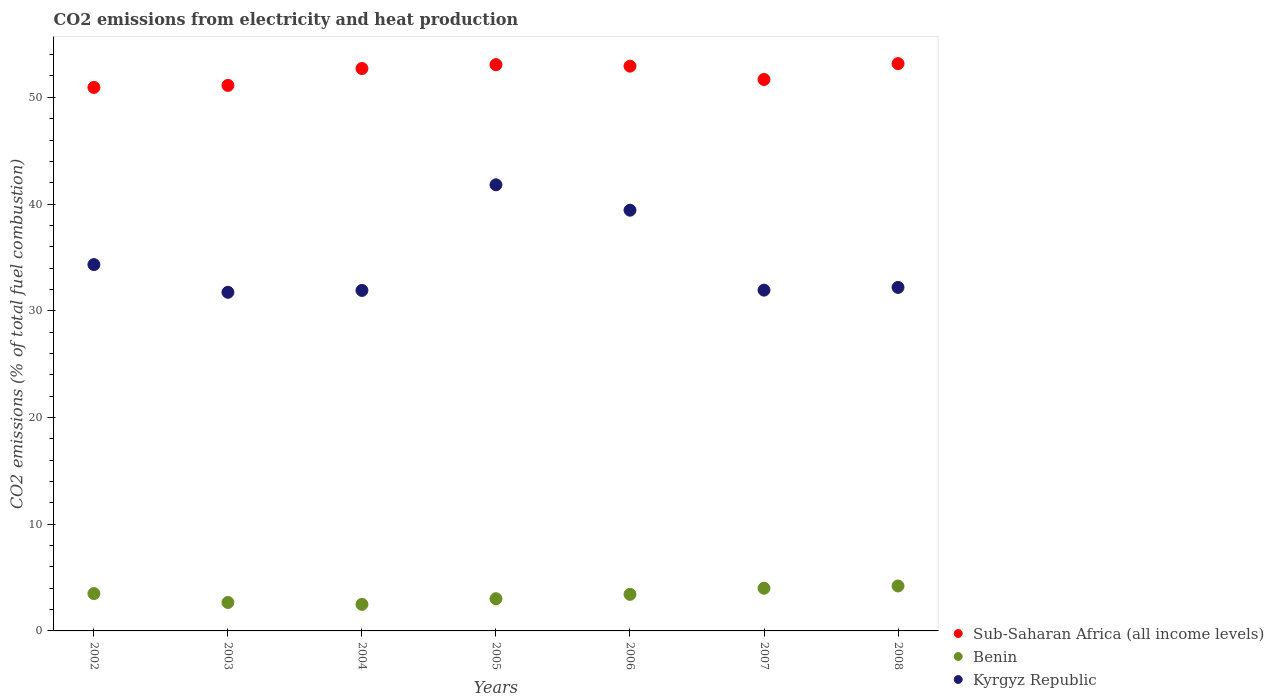How many different coloured dotlines are there?
Your answer should be compact. 3. What is the amount of CO2 emitted in Kyrgyz Republic in 2004?
Your answer should be very brief. 31.91. Across all years, what is the maximum amount of CO2 emitted in Benin?
Offer a terse response. 4.21. Across all years, what is the minimum amount of CO2 emitted in Benin?
Your answer should be very brief. 2.49. In which year was the amount of CO2 emitted in Sub-Saharan Africa (all income levels) minimum?
Provide a short and direct response. 2002. What is the total amount of CO2 emitted in Sub-Saharan Africa (all income levels) in the graph?
Provide a succinct answer. 365.57. What is the difference between the amount of CO2 emitted in Benin in 2005 and that in 2006?
Make the answer very short. -0.41. What is the difference between the amount of CO2 emitted in Benin in 2003 and the amount of CO2 emitted in Kyrgyz Republic in 2007?
Ensure brevity in your answer.  -29.27. What is the average amount of CO2 emitted in Sub-Saharan Africa (all income levels) per year?
Provide a short and direct response. 52.22. In the year 2006, what is the difference between the amount of CO2 emitted in Sub-Saharan Africa (all income levels) and amount of CO2 emitted in Benin?
Keep it short and to the point. 49.5. What is the ratio of the amount of CO2 emitted in Kyrgyz Republic in 2003 to that in 2007?
Offer a very short reply. 0.99. Is the difference between the amount of CO2 emitted in Sub-Saharan Africa (all income levels) in 2003 and 2007 greater than the difference between the amount of CO2 emitted in Benin in 2003 and 2007?
Provide a succinct answer. Yes. What is the difference between the highest and the second highest amount of CO2 emitted in Benin?
Provide a succinct answer. 0.21. What is the difference between the highest and the lowest amount of CO2 emitted in Kyrgyz Republic?
Provide a short and direct response. 10.07. In how many years, is the amount of CO2 emitted in Sub-Saharan Africa (all income levels) greater than the average amount of CO2 emitted in Sub-Saharan Africa (all income levels) taken over all years?
Offer a very short reply. 4. Is the sum of the amount of CO2 emitted in Benin in 2003 and 2005 greater than the maximum amount of CO2 emitted in Sub-Saharan Africa (all income levels) across all years?
Keep it short and to the point. No. Is it the case that in every year, the sum of the amount of CO2 emitted in Benin and amount of CO2 emitted in Kyrgyz Republic  is greater than the amount of CO2 emitted in Sub-Saharan Africa (all income levels)?
Give a very brief answer. No. How many years are there in the graph?
Provide a succinct answer. 7. What is the difference between two consecutive major ticks on the Y-axis?
Ensure brevity in your answer.  10. Are the values on the major ticks of Y-axis written in scientific E-notation?
Provide a succinct answer. No. Does the graph contain grids?
Provide a succinct answer. No. Where does the legend appear in the graph?
Provide a short and direct response. Bottom right. What is the title of the graph?
Keep it short and to the point. CO2 emissions from electricity and heat production. What is the label or title of the Y-axis?
Your answer should be compact. CO2 emissions (% of total fuel combustion). What is the CO2 emissions (% of total fuel combustion) in Sub-Saharan Africa (all income levels) in 2002?
Provide a short and direct response. 50.93. What is the CO2 emissions (% of total fuel combustion) in Benin in 2002?
Keep it short and to the point. 3.5. What is the CO2 emissions (% of total fuel combustion) of Kyrgyz Republic in 2002?
Provide a short and direct response. 34.33. What is the CO2 emissions (% of total fuel combustion) in Sub-Saharan Africa (all income levels) in 2003?
Give a very brief answer. 51.12. What is the CO2 emissions (% of total fuel combustion) of Benin in 2003?
Provide a short and direct response. 2.67. What is the CO2 emissions (% of total fuel combustion) of Kyrgyz Republic in 2003?
Keep it short and to the point. 31.73. What is the CO2 emissions (% of total fuel combustion) in Sub-Saharan Africa (all income levels) in 2004?
Your answer should be compact. 52.7. What is the CO2 emissions (% of total fuel combustion) in Benin in 2004?
Ensure brevity in your answer.  2.49. What is the CO2 emissions (% of total fuel combustion) of Kyrgyz Republic in 2004?
Offer a very short reply. 31.91. What is the CO2 emissions (% of total fuel combustion) of Sub-Saharan Africa (all income levels) in 2005?
Your response must be concise. 53.06. What is the CO2 emissions (% of total fuel combustion) of Benin in 2005?
Your answer should be compact. 3.02. What is the CO2 emissions (% of total fuel combustion) in Kyrgyz Republic in 2005?
Your answer should be compact. 41.8. What is the CO2 emissions (% of total fuel combustion) of Sub-Saharan Africa (all income levels) in 2006?
Offer a very short reply. 52.92. What is the CO2 emissions (% of total fuel combustion) in Benin in 2006?
Provide a short and direct response. 3.43. What is the CO2 emissions (% of total fuel combustion) in Kyrgyz Republic in 2006?
Offer a terse response. 39.43. What is the CO2 emissions (% of total fuel combustion) of Sub-Saharan Africa (all income levels) in 2007?
Make the answer very short. 51.67. What is the CO2 emissions (% of total fuel combustion) of Benin in 2007?
Offer a very short reply. 4. What is the CO2 emissions (% of total fuel combustion) of Kyrgyz Republic in 2007?
Give a very brief answer. 31.93. What is the CO2 emissions (% of total fuel combustion) of Sub-Saharan Africa (all income levels) in 2008?
Offer a very short reply. 53.16. What is the CO2 emissions (% of total fuel combustion) in Benin in 2008?
Provide a succinct answer. 4.21. What is the CO2 emissions (% of total fuel combustion) of Kyrgyz Republic in 2008?
Your response must be concise. 32.19. Across all years, what is the maximum CO2 emissions (% of total fuel combustion) in Sub-Saharan Africa (all income levels)?
Provide a short and direct response. 53.16. Across all years, what is the maximum CO2 emissions (% of total fuel combustion) in Benin?
Offer a terse response. 4.21. Across all years, what is the maximum CO2 emissions (% of total fuel combustion) in Kyrgyz Republic?
Your answer should be compact. 41.8. Across all years, what is the minimum CO2 emissions (% of total fuel combustion) of Sub-Saharan Africa (all income levels)?
Your response must be concise. 50.93. Across all years, what is the minimum CO2 emissions (% of total fuel combustion) in Benin?
Your response must be concise. 2.49. Across all years, what is the minimum CO2 emissions (% of total fuel combustion) of Kyrgyz Republic?
Provide a succinct answer. 31.73. What is the total CO2 emissions (% of total fuel combustion) in Sub-Saharan Africa (all income levels) in the graph?
Provide a succinct answer. 365.57. What is the total CO2 emissions (% of total fuel combustion) of Benin in the graph?
Provide a short and direct response. 23.31. What is the total CO2 emissions (% of total fuel combustion) of Kyrgyz Republic in the graph?
Your answer should be very brief. 243.32. What is the difference between the CO2 emissions (% of total fuel combustion) in Sub-Saharan Africa (all income levels) in 2002 and that in 2003?
Your response must be concise. -0.19. What is the difference between the CO2 emissions (% of total fuel combustion) in Benin in 2002 and that in 2003?
Make the answer very short. 0.83. What is the difference between the CO2 emissions (% of total fuel combustion) in Kyrgyz Republic in 2002 and that in 2003?
Your answer should be compact. 2.6. What is the difference between the CO2 emissions (% of total fuel combustion) of Sub-Saharan Africa (all income levels) in 2002 and that in 2004?
Ensure brevity in your answer.  -1.77. What is the difference between the CO2 emissions (% of total fuel combustion) in Benin in 2002 and that in 2004?
Offer a terse response. 1.01. What is the difference between the CO2 emissions (% of total fuel combustion) in Kyrgyz Republic in 2002 and that in 2004?
Make the answer very short. 2.42. What is the difference between the CO2 emissions (% of total fuel combustion) of Sub-Saharan Africa (all income levels) in 2002 and that in 2005?
Your answer should be compact. -2.13. What is the difference between the CO2 emissions (% of total fuel combustion) in Benin in 2002 and that in 2005?
Provide a short and direct response. 0.48. What is the difference between the CO2 emissions (% of total fuel combustion) of Kyrgyz Republic in 2002 and that in 2005?
Keep it short and to the point. -7.47. What is the difference between the CO2 emissions (% of total fuel combustion) of Sub-Saharan Africa (all income levels) in 2002 and that in 2006?
Offer a terse response. -1.99. What is the difference between the CO2 emissions (% of total fuel combustion) of Benin in 2002 and that in 2006?
Provide a succinct answer. 0.07. What is the difference between the CO2 emissions (% of total fuel combustion) of Kyrgyz Republic in 2002 and that in 2006?
Give a very brief answer. -5.1. What is the difference between the CO2 emissions (% of total fuel combustion) of Sub-Saharan Africa (all income levels) in 2002 and that in 2007?
Your answer should be very brief. -0.74. What is the difference between the CO2 emissions (% of total fuel combustion) of Kyrgyz Republic in 2002 and that in 2007?
Give a very brief answer. 2.4. What is the difference between the CO2 emissions (% of total fuel combustion) in Sub-Saharan Africa (all income levels) in 2002 and that in 2008?
Keep it short and to the point. -2.23. What is the difference between the CO2 emissions (% of total fuel combustion) in Benin in 2002 and that in 2008?
Your answer should be very brief. -0.71. What is the difference between the CO2 emissions (% of total fuel combustion) in Kyrgyz Republic in 2002 and that in 2008?
Your answer should be compact. 2.14. What is the difference between the CO2 emissions (% of total fuel combustion) of Sub-Saharan Africa (all income levels) in 2003 and that in 2004?
Give a very brief answer. -1.58. What is the difference between the CO2 emissions (% of total fuel combustion) in Benin in 2003 and that in 2004?
Make the answer very short. 0.18. What is the difference between the CO2 emissions (% of total fuel combustion) of Kyrgyz Republic in 2003 and that in 2004?
Keep it short and to the point. -0.18. What is the difference between the CO2 emissions (% of total fuel combustion) in Sub-Saharan Africa (all income levels) in 2003 and that in 2005?
Your answer should be very brief. -1.94. What is the difference between the CO2 emissions (% of total fuel combustion) in Benin in 2003 and that in 2005?
Give a very brief answer. -0.35. What is the difference between the CO2 emissions (% of total fuel combustion) in Kyrgyz Republic in 2003 and that in 2005?
Keep it short and to the point. -10.07. What is the difference between the CO2 emissions (% of total fuel combustion) of Sub-Saharan Africa (all income levels) in 2003 and that in 2006?
Your answer should be compact. -1.8. What is the difference between the CO2 emissions (% of total fuel combustion) in Benin in 2003 and that in 2006?
Make the answer very short. -0.76. What is the difference between the CO2 emissions (% of total fuel combustion) of Kyrgyz Republic in 2003 and that in 2006?
Keep it short and to the point. -7.69. What is the difference between the CO2 emissions (% of total fuel combustion) of Sub-Saharan Africa (all income levels) in 2003 and that in 2007?
Offer a terse response. -0.55. What is the difference between the CO2 emissions (% of total fuel combustion) in Benin in 2003 and that in 2007?
Offer a terse response. -1.33. What is the difference between the CO2 emissions (% of total fuel combustion) of Kyrgyz Republic in 2003 and that in 2007?
Ensure brevity in your answer.  -0.2. What is the difference between the CO2 emissions (% of total fuel combustion) of Sub-Saharan Africa (all income levels) in 2003 and that in 2008?
Ensure brevity in your answer.  -2.04. What is the difference between the CO2 emissions (% of total fuel combustion) of Benin in 2003 and that in 2008?
Keep it short and to the point. -1.54. What is the difference between the CO2 emissions (% of total fuel combustion) in Kyrgyz Republic in 2003 and that in 2008?
Offer a very short reply. -0.46. What is the difference between the CO2 emissions (% of total fuel combustion) in Sub-Saharan Africa (all income levels) in 2004 and that in 2005?
Give a very brief answer. -0.36. What is the difference between the CO2 emissions (% of total fuel combustion) in Benin in 2004 and that in 2005?
Your answer should be compact. -0.53. What is the difference between the CO2 emissions (% of total fuel combustion) in Kyrgyz Republic in 2004 and that in 2005?
Offer a very short reply. -9.9. What is the difference between the CO2 emissions (% of total fuel combustion) of Sub-Saharan Africa (all income levels) in 2004 and that in 2006?
Make the answer very short. -0.22. What is the difference between the CO2 emissions (% of total fuel combustion) in Benin in 2004 and that in 2006?
Your answer should be very brief. -0.94. What is the difference between the CO2 emissions (% of total fuel combustion) of Kyrgyz Republic in 2004 and that in 2006?
Provide a succinct answer. -7.52. What is the difference between the CO2 emissions (% of total fuel combustion) in Sub-Saharan Africa (all income levels) in 2004 and that in 2007?
Your answer should be very brief. 1.03. What is the difference between the CO2 emissions (% of total fuel combustion) of Benin in 2004 and that in 2007?
Ensure brevity in your answer.  -1.51. What is the difference between the CO2 emissions (% of total fuel combustion) in Kyrgyz Republic in 2004 and that in 2007?
Provide a succinct answer. -0.03. What is the difference between the CO2 emissions (% of total fuel combustion) of Sub-Saharan Africa (all income levels) in 2004 and that in 2008?
Your response must be concise. -0.46. What is the difference between the CO2 emissions (% of total fuel combustion) in Benin in 2004 and that in 2008?
Provide a succinct answer. -1.72. What is the difference between the CO2 emissions (% of total fuel combustion) in Kyrgyz Republic in 2004 and that in 2008?
Make the answer very short. -0.28. What is the difference between the CO2 emissions (% of total fuel combustion) in Sub-Saharan Africa (all income levels) in 2005 and that in 2006?
Keep it short and to the point. 0.14. What is the difference between the CO2 emissions (% of total fuel combustion) in Benin in 2005 and that in 2006?
Ensure brevity in your answer.  -0.41. What is the difference between the CO2 emissions (% of total fuel combustion) in Kyrgyz Republic in 2005 and that in 2006?
Your answer should be compact. 2.38. What is the difference between the CO2 emissions (% of total fuel combustion) of Sub-Saharan Africa (all income levels) in 2005 and that in 2007?
Offer a very short reply. 1.39. What is the difference between the CO2 emissions (% of total fuel combustion) in Benin in 2005 and that in 2007?
Offer a very short reply. -0.98. What is the difference between the CO2 emissions (% of total fuel combustion) in Kyrgyz Republic in 2005 and that in 2007?
Your answer should be compact. 9.87. What is the difference between the CO2 emissions (% of total fuel combustion) in Sub-Saharan Africa (all income levels) in 2005 and that in 2008?
Keep it short and to the point. -0.1. What is the difference between the CO2 emissions (% of total fuel combustion) in Benin in 2005 and that in 2008?
Your answer should be very brief. -1.19. What is the difference between the CO2 emissions (% of total fuel combustion) in Kyrgyz Republic in 2005 and that in 2008?
Your answer should be compact. 9.61. What is the difference between the CO2 emissions (% of total fuel combustion) of Sub-Saharan Africa (all income levels) in 2006 and that in 2007?
Ensure brevity in your answer.  1.25. What is the difference between the CO2 emissions (% of total fuel combustion) in Benin in 2006 and that in 2007?
Make the answer very short. -0.57. What is the difference between the CO2 emissions (% of total fuel combustion) in Kyrgyz Republic in 2006 and that in 2007?
Offer a terse response. 7.49. What is the difference between the CO2 emissions (% of total fuel combustion) in Sub-Saharan Africa (all income levels) in 2006 and that in 2008?
Give a very brief answer. -0.24. What is the difference between the CO2 emissions (% of total fuel combustion) of Benin in 2006 and that in 2008?
Make the answer very short. -0.78. What is the difference between the CO2 emissions (% of total fuel combustion) of Kyrgyz Republic in 2006 and that in 2008?
Make the answer very short. 7.24. What is the difference between the CO2 emissions (% of total fuel combustion) of Sub-Saharan Africa (all income levels) in 2007 and that in 2008?
Your response must be concise. -1.49. What is the difference between the CO2 emissions (% of total fuel combustion) in Benin in 2007 and that in 2008?
Provide a short and direct response. -0.21. What is the difference between the CO2 emissions (% of total fuel combustion) in Kyrgyz Republic in 2007 and that in 2008?
Offer a terse response. -0.26. What is the difference between the CO2 emissions (% of total fuel combustion) of Sub-Saharan Africa (all income levels) in 2002 and the CO2 emissions (% of total fuel combustion) of Benin in 2003?
Give a very brief answer. 48.26. What is the difference between the CO2 emissions (% of total fuel combustion) in Sub-Saharan Africa (all income levels) in 2002 and the CO2 emissions (% of total fuel combustion) in Kyrgyz Republic in 2003?
Offer a terse response. 19.2. What is the difference between the CO2 emissions (% of total fuel combustion) in Benin in 2002 and the CO2 emissions (% of total fuel combustion) in Kyrgyz Republic in 2003?
Make the answer very short. -28.23. What is the difference between the CO2 emissions (% of total fuel combustion) of Sub-Saharan Africa (all income levels) in 2002 and the CO2 emissions (% of total fuel combustion) of Benin in 2004?
Your response must be concise. 48.44. What is the difference between the CO2 emissions (% of total fuel combustion) in Sub-Saharan Africa (all income levels) in 2002 and the CO2 emissions (% of total fuel combustion) in Kyrgyz Republic in 2004?
Provide a succinct answer. 19.02. What is the difference between the CO2 emissions (% of total fuel combustion) of Benin in 2002 and the CO2 emissions (% of total fuel combustion) of Kyrgyz Republic in 2004?
Offer a very short reply. -28.41. What is the difference between the CO2 emissions (% of total fuel combustion) of Sub-Saharan Africa (all income levels) in 2002 and the CO2 emissions (% of total fuel combustion) of Benin in 2005?
Offer a terse response. 47.91. What is the difference between the CO2 emissions (% of total fuel combustion) in Sub-Saharan Africa (all income levels) in 2002 and the CO2 emissions (% of total fuel combustion) in Kyrgyz Republic in 2005?
Your response must be concise. 9.13. What is the difference between the CO2 emissions (% of total fuel combustion) of Benin in 2002 and the CO2 emissions (% of total fuel combustion) of Kyrgyz Republic in 2005?
Offer a terse response. -38.3. What is the difference between the CO2 emissions (% of total fuel combustion) of Sub-Saharan Africa (all income levels) in 2002 and the CO2 emissions (% of total fuel combustion) of Benin in 2006?
Offer a very short reply. 47.5. What is the difference between the CO2 emissions (% of total fuel combustion) in Sub-Saharan Africa (all income levels) in 2002 and the CO2 emissions (% of total fuel combustion) in Kyrgyz Republic in 2006?
Provide a short and direct response. 11.5. What is the difference between the CO2 emissions (% of total fuel combustion) of Benin in 2002 and the CO2 emissions (% of total fuel combustion) of Kyrgyz Republic in 2006?
Your response must be concise. -35.93. What is the difference between the CO2 emissions (% of total fuel combustion) of Sub-Saharan Africa (all income levels) in 2002 and the CO2 emissions (% of total fuel combustion) of Benin in 2007?
Offer a very short reply. 46.93. What is the difference between the CO2 emissions (% of total fuel combustion) of Sub-Saharan Africa (all income levels) in 2002 and the CO2 emissions (% of total fuel combustion) of Kyrgyz Republic in 2007?
Provide a short and direct response. 19. What is the difference between the CO2 emissions (% of total fuel combustion) of Benin in 2002 and the CO2 emissions (% of total fuel combustion) of Kyrgyz Republic in 2007?
Provide a succinct answer. -28.43. What is the difference between the CO2 emissions (% of total fuel combustion) in Sub-Saharan Africa (all income levels) in 2002 and the CO2 emissions (% of total fuel combustion) in Benin in 2008?
Provide a succinct answer. 46.72. What is the difference between the CO2 emissions (% of total fuel combustion) in Sub-Saharan Africa (all income levels) in 2002 and the CO2 emissions (% of total fuel combustion) in Kyrgyz Republic in 2008?
Give a very brief answer. 18.74. What is the difference between the CO2 emissions (% of total fuel combustion) in Benin in 2002 and the CO2 emissions (% of total fuel combustion) in Kyrgyz Republic in 2008?
Your response must be concise. -28.69. What is the difference between the CO2 emissions (% of total fuel combustion) of Sub-Saharan Africa (all income levels) in 2003 and the CO2 emissions (% of total fuel combustion) of Benin in 2004?
Ensure brevity in your answer.  48.63. What is the difference between the CO2 emissions (% of total fuel combustion) in Sub-Saharan Africa (all income levels) in 2003 and the CO2 emissions (% of total fuel combustion) in Kyrgyz Republic in 2004?
Your response must be concise. 19.21. What is the difference between the CO2 emissions (% of total fuel combustion) of Benin in 2003 and the CO2 emissions (% of total fuel combustion) of Kyrgyz Republic in 2004?
Your answer should be very brief. -29.24. What is the difference between the CO2 emissions (% of total fuel combustion) of Sub-Saharan Africa (all income levels) in 2003 and the CO2 emissions (% of total fuel combustion) of Benin in 2005?
Give a very brief answer. 48.1. What is the difference between the CO2 emissions (% of total fuel combustion) in Sub-Saharan Africa (all income levels) in 2003 and the CO2 emissions (% of total fuel combustion) in Kyrgyz Republic in 2005?
Your answer should be very brief. 9.32. What is the difference between the CO2 emissions (% of total fuel combustion) of Benin in 2003 and the CO2 emissions (% of total fuel combustion) of Kyrgyz Republic in 2005?
Your answer should be compact. -39.14. What is the difference between the CO2 emissions (% of total fuel combustion) in Sub-Saharan Africa (all income levels) in 2003 and the CO2 emissions (% of total fuel combustion) in Benin in 2006?
Offer a very short reply. 47.69. What is the difference between the CO2 emissions (% of total fuel combustion) of Sub-Saharan Africa (all income levels) in 2003 and the CO2 emissions (% of total fuel combustion) of Kyrgyz Republic in 2006?
Your answer should be very brief. 11.69. What is the difference between the CO2 emissions (% of total fuel combustion) of Benin in 2003 and the CO2 emissions (% of total fuel combustion) of Kyrgyz Republic in 2006?
Offer a terse response. -36.76. What is the difference between the CO2 emissions (% of total fuel combustion) in Sub-Saharan Africa (all income levels) in 2003 and the CO2 emissions (% of total fuel combustion) in Benin in 2007?
Ensure brevity in your answer.  47.12. What is the difference between the CO2 emissions (% of total fuel combustion) of Sub-Saharan Africa (all income levels) in 2003 and the CO2 emissions (% of total fuel combustion) of Kyrgyz Republic in 2007?
Offer a terse response. 19.19. What is the difference between the CO2 emissions (% of total fuel combustion) in Benin in 2003 and the CO2 emissions (% of total fuel combustion) in Kyrgyz Republic in 2007?
Your response must be concise. -29.27. What is the difference between the CO2 emissions (% of total fuel combustion) of Sub-Saharan Africa (all income levels) in 2003 and the CO2 emissions (% of total fuel combustion) of Benin in 2008?
Ensure brevity in your answer.  46.91. What is the difference between the CO2 emissions (% of total fuel combustion) of Sub-Saharan Africa (all income levels) in 2003 and the CO2 emissions (% of total fuel combustion) of Kyrgyz Republic in 2008?
Ensure brevity in your answer.  18.93. What is the difference between the CO2 emissions (% of total fuel combustion) in Benin in 2003 and the CO2 emissions (% of total fuel combustion) in Kyrgyz Republic in 2008?
Make the answer very short. -29.52. What is the difference between the CO2 emissions (% of total fuel combustion) of Sub-Saharan Africa (all income levels) in 2004 and the CO2 emissions (% of total fuel combustion) of Benin in 2005?
Make the answer very short. 49.68. What is the difference between the CO2 emissions (% of total fuel combustion) in Sub-Saharan Africa (all income levels) in 2004 and the CO2 emissions (% of total fuel combustion) in Kyrgyz Republic in 2005?
Ensure brevity in your answer.  10.9. What is the difference between the CO2 emissions (% of total fuel combustion) in Benin in 2004 and the CO2 emissions (% of total fuel combustion) in Kyrgyz Republic in 2005?
Ensure brevity in your answer.  -39.31. What is the difference between the CO2 emissions (% of total fuel combustion) in Sub-Saharan Africa (all income levels) in 2004 and the CO2 emissions (% of total fuel combustion) in Benin in 2006?
Ensure brevity in your answer.  49.28. What is the difference between the CO2 emissions (% of total fuel combustion) in Sub-Saharan Africa (all income levels) in 2004 and the CO2 emissions (% of total fuel combustion) in Kyrgyz Republic in 2006?
Offer a terse response. 13.28. What is the difference between the CO2 emissions (% of total fuel combustion) of Benin in 2004 and the CO2 emissions (% of total fuel combustion) of Kyrgyz Republic in 2006?
Make the answer very short. -36.94. What is the difference between the CO2 emissions (% of total fuel combustion) in Sub-Saharan Africa (all income levels) in 2004 and the CO2 emissions (% of total fuel combustion) in Benin in 2007?
Provide a succinct answer. 48.7. What is the difference between the CO2 emissions (% of total fuel combustion) of Sub-Saharan Africa (all income levels) in 2004 and the CO2 emissions (% of total fuel combustion) of Kyrgyz Republic in 2007?
Give a very brief answer. 20.77. What is the difference between the CO2 emissions (% of total fuel combustion) of Benin in 2004 and the CO2 emissions (% of total fuel combustion) of Kyrgyz Republic in 2007?
Your response must be concise. -29.44. What is the difference between the CO2 emissions (% of total fuel combustion) of Sub-Saharan Africa (all income levels) in 2004 and the CO2 emissions (% of total fuel combustion) of Benin in 2008?
Your answer should be very brief. 48.49. What is the difference between the CO2 emissions (% of total fuel combustion) of Sub-Saharan Africa (all income levels) in 2004 and the CO2 emissions (% of total fuel combustion) of Kyrgyz Republic in 2008?
Your answer should be very brief. 20.51. What is the difference between the CO2 emissions (% of total fuel combustion) in Benin in 2004 and the CO2 emissions (% of total fuel combustion) in Kyrgyz Republic in 2008?
Keep it short and to the point. -29.7. What is the difference between the CO2 emissions (% of total fuel combustion) of Sub-Saharan Africa (all income levels) in 2005 and the CO2 emissions (% of total fuel combustion) of Benin in 2006?
Provide a succinct answer. 49.64. What is the difference between the CO2 emissions (% of total fuel combustion) in Sub-Saharan Africa (all income levels) in 2005 and the CO2 emissions (% of total fuel combustion) in Kyrgyz Republic in 2006?
Give a very brief answer. 13.64. What is the difference between the CO2 emissions (% of total fuel combustion) of Benin in 2005 and the CO2 emissions (% of total fuel combustion) of Kyrgyz Republic in 2006?
Provide a short and direct response. -36.41. What is the difference between the CO2 emissions (% of total fuel combustion) of Sub-Saharan Africa (all income levels) in 2005 and the CO2 emissions (% of total fuel combustion) of Benin in 2007?
Ensure brevity in your answer.  49.06. What is the difference between the CO2 emissions (% of total fuel combustion) in Sub-Saharan Africa (all income levels) in 2005 and the CO2 emissions (% of total fuel combustion) in Kyrgyz Republic in 2007?
Your answer should be compact. 21.13. What is the difference between the CO2 emissions (% of total fuel combustion) of Benin in 2005 and the CO2 emissions (% of total fuel combustion) of Kyrgyz Republic in 2007?
Provide a succinct answer. -28.91. What is the difference between the CO2 emissions (% of total fuel combustion) in Sub-Saharan Africa (all income levels) in 2005 and the CO2 emissions (% of total fuel combustion) in Benin in 2008?
Make the answer very short. 48.85. What is the difference between the CO2 emissions (% of total fuel combustion) of Sub-Saharan Africa (all income levels) in 2005 and the CO2 emissions (% of total fuel combustion) of Kyrgyz Republic in 2008?
Keep it short and to the point. 20.87. What is the difference between the CO2 emissions (% of total fuel combustion) of Benin in 2005 and the CO2 emissions (% of total fuel combustion) of Kyrgyz Republic in 2008?
Keep it short and to the point. -29.17. What is the difference between the CO2 emissions (% of total fuel combustion) in Sub-Saharan Africa (all income levels) in 2006 and the CO2 emissions (% of total fuel combustion) in Benin in 2007?
Give a very brief answer. 48.92. What is the difference between the CO2 emissions (% of total fuel combustion) in Sub-Saharan Africa (all income levels) in 2006 and the CO2 emissions (% of total fuel combustion) in Kyrgyz Republic in 2007?
Keep it short and to the point. 20.99. What is the difference between the CO2 emissions (% of total fuel combustion) in Benin in 2006 and the CO2 emissions (% of total fuel combustion) in Kyrgyz Republic in 2007?
Keep it short and to the point. -28.51. What is the difference between the CO2 emissions (% of total fuel combustion) of Sub-Saharan Africa (all income levels) in 2006 and the CO2 emissions (% of total fuel combustion) of Benin in 2008?
Provide a short and direct response. 48.71. What is the difference between the CO2 emissions (% of total fuel combustion) of Sub-Saharan Africa (all income levels) in 2006 and the CO2 emissions (% of total fuel combustion) of Kyrgyz Republic in 2008?
Your response must be concise. 20.73. What is the difference between the CO2 emissions (% of total fuel combustion) of Benin in 2006 and the CO2 emissions (% of total fuel combustion) of Kyrgyz Republic in 2008?
Offer a terse response. -28.76. What is the difference between the CO2 emissions (% of total fuel combustion) of Sub-Saharan Africa (all income levels) in 2007 and the CO2 emissions (% of total fuel combustion) of Benin in 2008?
Give a very brief answer. 47.46. What is the difference between the CO2 emissions (% of total fuel combustion) in Sub-Saharan Africa (all income levels) in 2007 and the CO2 emissions (% of total fuel combustion) in Kyrgyz Republic in 2008?
Offer a terse response. 19.48. What is the difference between the CO2 emissions (% of total fuel combustion) in Benin in 2007 and the CO2 emissions (% of total fuel combustion) in Kyrgyz Republic in 2008?
Offer a terse response. -28.19. What is the average CO2 emissions (% of total fuel combustion) in Sub-Saharan Africa (all income levels) per year?
Provide a short and direct response. 52.22. What is the average CO2 emissions (% of total fuel combustion) of Benin per year?
Make the answer very short. 3.33. What is the average CO2 emissions (% of total fuel combustion) of Kyrgyz Republic per year?
Ensure brevity in your answer.  34.76. In the year 2002, what is the difference between the CO2 emissions (% of total fuel combustion) of Sub-Saharan Africa (all income levels) and CO2 emissions (% of total fuel combustion) of Benin?
Provide a short and direct response. 47.43. In the year 2002, what is the difference between the CO2 emissions (% of total fuel combustion) in Sub-Saharan Africa (all income levels) and CO2 emissions (% of total fuel combustion) in Kyrgyz Republic?
Your response must be concise. 16.6. In the year 2002, what is the difference between the CO2 emissions (% of total fuel combustion) of Benin and CO2 emissions (% of total fuel combustion) of Kyrgyz Republic?
Provide a short and direct response. -30.83. In the year 2003, what is the difference between the CO2 emissions (% of total fuel combustion) of Sub-Saharan Africa (all income levels) and CO2 emissions (% of total fuel combustion) of Benin?
Your response must be concise. 48.45. In the year 2003, what is the difference between the CO2 emissions (% of total fuel combustion) in Sub-Saharan Africa (all income levels) and CO2 emissions (% of total fuel combustion) in Kyrgyz Republic?
Ensure brevity in your answer.  19.39. In the year 2003, what is the difference between the CO2 emissions (% of total fuel combustion) in Benin and CO2 emissions (% of total fuel combustion) in Kyrgyz Republic?
Offer a very short reply. -29.06. In the year 2004, what is the difference between the CO2 emissions (% of total fuel combustion) in Sub-Saharan Africa (all income levels) and CO2 emissions (% of total fuel combustion) in Benin?
Your response must be concise. 50.21. In the year 2004, what is the difference between the CO2 emissions (% of total fuel combustion) in Sub-Saharan Africa (all income levels) and CO2 emissions (% of total fuel combustion) in Kyrgyz Republic?
Your answer should be very brief. 20.8. In the year 2004, what is the difference between the CO2 emissions (% of total fuel combustion) in Benin and CO2 emissions (% of total fuel combustion) in Kyrgyz Republic?
Offer a terse response. -29.42. In the year 2005, what is the difference between the CO2 emissions (% of total fuel combustion) in Sub-Saharan Africa (all income levels) and CO2 emissions (% of total fuel combustion) in Benin?
Offer a very short reply. 50.04. In the year 2005, what is the difference between the CO2 emissions (% of total fuel combustion) in Sub-Saharan Africa (all income levels) and CO2 emissions (% of total fuel combustion) in Kyrgyz Republic?
Provide a succinct answer. 11.26. In the year 2005, what is the difference between the CO2 emissions (% of total fuel combustion) of Benin and CO2 emissions (% of total fuel combustion) of Kyrgyz Republic?
Give a very brief answer. -38.78. In the year 2006, what is the difference between the CO2 emissions (% of total fuel combustion) of Sub-Saharan Africa (all income levels) and CO2 emissions (% of total fuel combustion) of Benin?
Your answer should be compact. 49.5. In the year 2006, what is the difference between the CO2 emissions (% of total fuel combustion) in Sub-Saharan Africa (all income levels) and CO2 emissions (% of total fuel combustion) in Kyrgyz Republic?
Ensure brevity in your answer.  13.5. In the year 2006, what is the difference between the CO2 emissions (% of total fuel combustion) of Benin and CO2 emissions (% of total fuel combustion) of Kyrgyz Republic?
Your response must be concise. -36. In the year 2007, what is the difference between the CO2 emissions (% of total fuel combustion) in Sub-Saharan Africa (all income levels) and CO2 emissions (% of total fuel combustion) in Benin?
Ensure brevity in your answer.  47.67. In the year 2007, what is the difference between the CO2 emissions (% of total fuel combustion) of Sub-Saharan Africa (all income levels) and CO2 emissions (% of total fuel combustion) of Kyrgyz Republic?
Give a very brief answer. 19.74. In the year 2007, what is the difference between the CO2 emissions (% of total fuel combustion) of Benin and CO2 emissions (% of total fuel combustion) of Kyrgyz Republic?
Your answer should be compact. -27.93. In the year 2008, what is the difference between the CO2 emissions (% of total fuel combustion) in Sub-Saharan Africa (all income levels) and CO2 emissions (% of total fuel combustion) in Benin?
Offer a very short reply. 48.95. In the year 2008, what is the difference between the CO2 emissions (% of total fuel combustion) in Sub-Saharan Africa (all income levels) and CO2 emissions (% of total fuel combustion) in Kyrgyz Republic?
Offer a very short reply. 20.97. In the year 2008, what is the difference between the CO2 emissions (% of total fuel combustion) in Benin and CO2 emissions (% of total fuel combustion) in Kyrgyz Republic?
Your answer should be compact. -27.98. What is the ratio of the CO2 emissions (% of total fuel combustion) in Benin in 2002 to that in 2003?
Offer a very short reply. 1.31. What is the ratio of the CO2 emissions (% of total fuel combustion) in Kyrgyz Republic in 2002 to that in 2003?
Make the answer very short. 1.08. What is the ratio of the CO2 emissions (% of total fuel combustion) in Sub-Saharan Africa (all income levels) in 2002 to that in 2004?
Provide a succinct answer. 0.97. What is the ratio of the CO2 emissions (% of total fuel combustion) in Benin in 2002 to that in 2004?
Offer a terse response. 1.41. What is the ratio of the CO2 emissions (% of total fuel combustion) of Kyrgyz Republic in 2002 to that in 2004?
Ensure brevity in your answer.  1.08. What is the ratio of the CO2 emissions (% of total fuel combustion) in Sub-Saharan Africa (all income levels) in 2002 to that in 2005?
Ensure brevity in your answer.  0.96. What is the ratio of the CO2 emissions (% of total fuel combustion) of Benin in 2002 to that in 2005?
Offer a very short reply. 1.16. What is the ratio of the CO2 emissions (% of total fuel combustion) in Kyrgyz Republic in 2002 to that in 2005?
Your response must be concise. 0.82. What is the ratio of the CO2 emissions (% of total fuel combustion) of Sub-Saharan Africa (all income levels) in 2002 to that in 2006?
Your answer should be compact. 0.96. What is the ratio of the CO2 emissions (% of total fuel combustion) of Benin in 2002 to that in 2006?
Your response must be concise. 1.02. What is the ratio of the CO2 emissions (% of total fuel combustion) in Kyrgyz Republic in 2002 to that in 2006?
Your response must be concise. 0.87. What is the ratio of the CO2 emissions (% of total fuel combustion) of Sub-Saharan Africa (all income levels) in 2002 to that in 2007?
Ensure brevity in your answer.  0.99. What is the ratio of the CO2 emissions (% of total fuel combustion) in Kyrgyz Republic in 2002 to that in 2007?
Provide a short and direct response. 1.07. What is the ratio of the CO2 emissions (% of total fuel combustion) of Sub-Saharan Africa (all income levels) in 2002 to that in 2008?
Give a very brief answer. 0.96. What is the ratio of the CO2 emissions (% of total fuel combustion) of Benin in 2002 to that in 2008?
Provide a short and direct response. 0.83. What is the ratio of the CO2 emissions (% of total fuel combustion) of Kyrgyz Republic in 2002 to that in 2008?
Your response must be concise. 1.07. What is the ratio of the CO2 emissions (% of total fuel combustion) in Benin in 2003 to that in 2004?
Provide a succinct answer. 1.07. What is the ratio of the CO2 emissions (% of total fuel combustion) in Kyrgyz Republic in 2003 to that in 2004?
Your response must be concise. 0.99. What is the ratio of the CO2 emissions (% of total fuel combustion) of Sub-Saharan Africa (all income levels) in 2003 to that in 2005?
Provide a succinct answer. 0.96. What is the ratio of the CO2 emissions (% of total fuel combustion) of Benin in 2003 to that in 2005?
Provide a short and direct response. 0.88. What is the ratio of the CO2 emissions (% of total fuel combustion) of Kyrgyz Republic in 2003 to that in 2005?
Your answer should be compact. 0.76. What is the ratio of the CO2 emissions (% of total fuel combustion) in Sub-Saharan Africa (all income levels) in 2003 to that in 2006?
Offer a terse response. 0.97. What is the ratio of the CO2 emissions (% of total fuel combustion) of Benin in 2003 to that in 2006?
Your answer should be very brief. 0.78. What is the ratio of the CO2 emissions (% of total fuel combustion) of Kyrgyz Republic in 2003 to that in 2006?
Offer a terse response. 0.8. What is the ratio of the CO2 emissions (% of total fuel combustion) of Sub-Saharan Africa (all income levels) in 2003 to that in 2007?
Offer a very short reply. 0.99. What is the ratio of the CO2 emissions (% of total fuel combustion) of Benin in 2003 to that in 2007?
Your answer should be very brief. 0.67. What is the ratio of the CO2 emissions (% of total fuel combustion) of Sub-Saharan Africa (all income levels) in 2003 to that in 2008?
Your answer should be compact. 0.96. What is the ratio of the CO2 emissions (% of total fuel combustion) in Benin in 2003 to that in 2008?
Provide a short and direct response. 0.63. What is the ratio of the CO2 emissions (% of total fuel combustion) in Kyrgyz Republic in 2003 to that in 2008?
Offer a terse response. 0.99. What is the ratio of the CO2 emissions (% of total fuel combustion) of Benin in 2004 to that in 2005?
Your response must be concise. 0.82. What is the ratio of the CO2 emissions (% of total fuel combustion) of Kyrgyz Republic in 2004 to that in 2005?
Keep it short and to the point. 0.76. What is the ratio of the CO2 emissions (% of total fuel combustion) of Benin in 2004 to that in 2006?
Keep it short and to the point. 0.73. What is the ratio of the CO2 emissions (% of total fuel combustion) of Kyrgyz Republic in 2004 to that in 2006?
Offer a very short reply. 0.81. What is the ratio of the CO2 emissions (% of total fuel combustion) of Sub-Saharan Africa (all income levels) in 2004 to that in 2007?
Your answer should be compact. 1.02. What is the ratio of the CO2 emissions (% of total fuel combustion) of Benin in 2004 to that in 2007?
Provide a short and direct response. 0.62. What is the ratio of the CO2 emissions (% of total fuel combustion) in Sub-Saharan Africa (all income levels) in 2004 to that in 2008?
Ensure brevity in your answer.  0.99. What is the ratio of the CO2 emissions (% of total fuel combustion) of Benin in 2004 to that in 2008?
Give a very brief answer. 0.59. What is the ratio of the CO2 emissions (% of total fuel combustion) of Sub-Saharan Africa (all income levels) in 2005 to that in 2006?
Your answer should be compact. 1. What is the ratio of the CO2 emissions (% of total fuel combustion) of Benin in 2005 to that in 2006?
Give a very brief answer. 0.88. What is the ratio of the CO2 emissions (% of total fuel combustion) of Kyrgyz Republic in 2005 to that in 2006?
Provide a short and direct response. 1.06. What is the ratio of the CO2 emissions (% of total fuel combustion) of Sub-Saharan Africa (all income levels) in 2005 to that in 2007?
Provide a short and direct response. 1.03. What is the ratio of the CO2 emissions (% of total fuel combustion) in Benin in 2005 to that in 2007?
Provide a short and direct response. 0.75. What is the ratio of the CO2 emissions (% of total fuel combustion) in Kyrgyz Republic in 2005 to that in 2007?
Keep it short and to the point. 1.31. What is the ratio of the CO2 emissions (% of total fuel combustion) of Benin in 2005 to that in 2008?
Your response must be concise. 0.72. What is the ratio of the CO2 emissions (% of total fuel combustion) in Kyrgyz Republic in 2005 to that in 2008?
Your answer should be compact. 1.3. What is the ratio of the CO2 emissions (% of total fuel combustion) of Sub-Saharan Africa (all income levels) in 2006 to that in 2007?
Offer a very short reply. 1.02. What is the ratio of the CO2 emissions (% of total fuel combustion) of Benin in 2006 to that in 2007?
Offer a terse response. 0.86. What is the ratio of the CO2 emissions (% of total fuel combustion) in Kyrgyz Republic in 2006 to that in 2007?
Ensure brevity in your answer.  1.23. What is the ratio of the CO2 emissions (% of total fuel combustion) of Benin in 2006 to that in 2008?
Your answer should be compact. 0.81. What is the ratio of the CO2 emissions (% of total fuel combustion) of Kyrgyz Republic in 2006 to that in 2008?
Your answer should be compact. 1.22. What is the ratio of the CO2 emissions (% of total fuel combustion) of Benin in 2007 to that in 2008?
Your response must be concise. 0.95. What is the difference between the highest and the second highest CO2 emissions (% of total fuel combustion) in Sub-Saharan Africa (all income levels)?
Offer a terse response. 0.1. What is the difference between the highest and the second highest CO2 emissions (% of total fuel combustion) in Benin?
Offer a terse response. 0.21. What is the difference between the highest and the second highest CO2 emissions (% of total fuel combustion) in Kyrgyz Republic?
Provide a short and direct response. 2.38. What is the difference between the highest and the lowest CO2 emissions (% of total fuel combustion) of Sub-Saharan Africa (all income levels)?
Provide a succinct answer. 2.23. What is the difference between the highest and the lowest CO2 emissions (% of total fuel combustion) of Benin?
Provide a succinct answer. 1.72. What is the difference between the highest and the lowest CO2 emissions (% of total fuel combustion) of Kyrgyz Republic?
Your response must be concise. 10.07. 